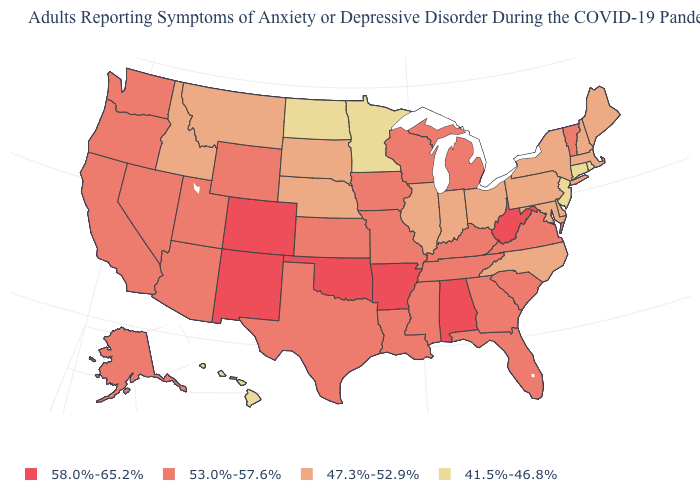What is the highest value in states that border Iowa?
Quick response, please. 53.0%-57.6%. Which states hav the highest value in the MidWest?
Concise answer only. Iowa, Kansas, Michigan, Missouri, Wisconsin. Among the states that border New York , does Vermont have the highest value?
Keep it brief. Yes. What is the value of Oklahoma?
Quick response, please. 58.0%-65.2%. Name the states that have a value in the range 53.0%-57.6%?
Answer briefly. Alaska, Arizona, California, Florida, Georgia, Iowa, Kansas, Kentucky, Louisiana, Michigan, Mississippi, Missouri, Nevada, Oregon, South Carolina, Tennessee, Texas, Utah, Vermont, Virginia, Washington, Wisconsin, Wyoming. What is the value of Maryland?
Quick response, please. 47.3%-52.9%. What is the value of Colorado?
Answer briefly. 58.0%-65.2%. Among the states that border Massachusetts , which have the lowest value?
Answer briefly. Connecticut, Rhode Island. What is the highest value in the USA?
Be succinct. 58.0%-65.2%. What is the value of Missouri?
Quick response, please. 53.0%-57.6%. Does the first symbol in the legend represent the smallest category?
Keep it brief. No. Name the states that have a value in the range 41.5%-46.8%?
Give a very brief answer. Connecticut, Hawaii, Minnesota, New Jersey, North Dakota, Rhode Island. Does the map have missing data?
Give a very brief answer. No. Is the legend a continuous bar?
Concise answer only. No. How many symbols are there in the legend?
Be succinct. 4. 